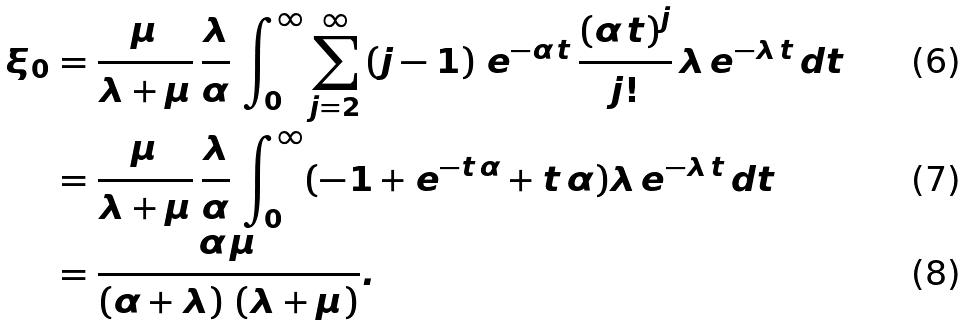Convert formula to latex. <formula><loc_0><loc_0><loc_500><loc_500>\xi _ { 0 } & = \frac { \mu } { \lambda + \mu } \, \frac { \lambda } { \alpha } \, \int _ { 0 } ^ { \infty } \sum _ { j = 2 } ^ { \infty } \left ( j - 1 \right ) \, e ^ { - \alpha \, t } \, \frac { { \left ( \alpha \, t \right ) } ^ { j } } { j ! } \, \lambda \, e ^ { - \lambda \, t } \, d t \\ & = \frac { \mu } { \lambda + \mu } \, \frac { \lambda } { \alpha } \, \int _ { 0 } ^ { \infty } ( - 1 + e ^ { - t \, \alpha } + t \, \alpha ) \lambda \, e ^ { - \lambda \, t } \, d t \\ & = \frac { \alpha \, \mu } { \left ( \alpha + \lambda \right ) \, \left ( \lambda + \mu \right ) } .</formula> 